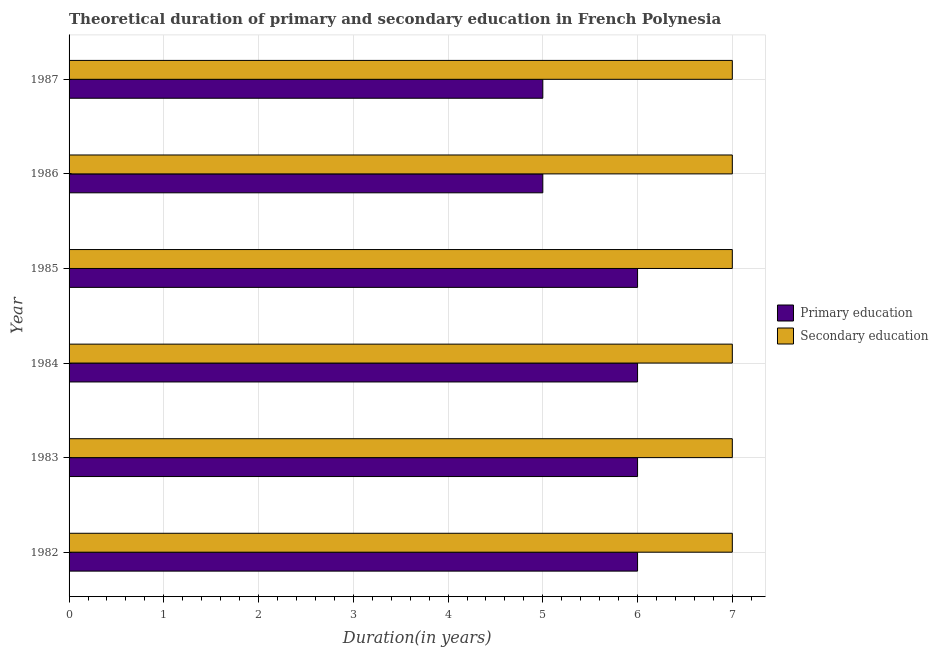How many different coloured bars are there?
Offer a terse response. 2. How many bars are there on the 3rd tick from the top?
Ensure brevity in your answer.  2. How many bars are there on the 1st tick from the bottom?
Your answer should be compact. 2. In how many cases, is the number of bars for a given year not equal to the number of legend labels?
Your answer should be very brief. 0. What is the duration of secondary education in 1986?
Provide a short and direct response. 7. Across all years, what is the maximum duration of secondary education?
Keep it short and to the point. 7. Across all years, what is the minimum duration of primary education?
Offer a terse response. 5. What is the total duration of secondary education in the graph?
Offer a terse response. 42. What is the difference between the duration of secondary education in 1983 and that in 1985?
Provide a short and direct response. 0. What is the difference between the duration of secondary education in 1984 and the duration of primary education in 1983?
Your answer should be compact. 1. What is the average duration of secondary education per year?
Keep it short and to the point. 7. In the year 1983, what is the difference between the duration of primary education and duration of secondary education?
Provide a succinct answer. -1. In how many years, is the duration of primary education greater than 3.4 years?
Ensure brevity in your answer.  6. What is the ratio of the duration of primary education in 1983 to that in 1986?
Ensure brevity in your answer.  1.2. What is the difference between the highest and the lowest duration of primary education?
Offer a terse response. 1. Is the sum of the duration of primary education in 1985 and 1987 greater than the maximum duration of secondary education across all years?
Your answer should be compact. Yes. What does the 2nd bar from the bottom in 1983 represents?
Give a very brief answer. Secondary education. What is the difference between two consecutive major ticks on the X-axis?
Give a very brief answer. 1. Are the values on the major ticks of X-axis written in scientific E-notation?
Provide a succinct answer. No. Does the graph contain any zero values?
Provide a succinct answer. No. Does the graph contain grids?
Keep it short and to the point. Yes. How are the legend labels stacked?
Give a very brief answer. Vertical. What is the title of the graph?
Provide a short and direct response. Theoretical duration of primary and secondary education in French Polynesia. What is the label or title of the X-axis?
Offer a terse response. Duration(in years). What is the label or title of the Y-axis?
Your response must be concise. Year. What is the Duration(in years) of Primary education in 1982?
Keep it short and to the point. 6. What is the Duration(in years) of Secondary education in 1983?
Provide a short and direct response. 7. What is the Duration(in years) in Primary education in 1985?
Ensure brevity in your answer.  6. What is the Duration(in years) of Primary education in 1987?
Keep it short and to the point. 5. What is the Duration(in years) of Secondary education in 1987?
Offer a very short reply. 7. Across all years, what is the minimum Duration(in years) in Primary education?
Provide a short and direct response. 5. What is the difference between the Duration(in years) in Secondary education in 1982 and that in 1983?
Offer a very short reply. 0. What is the difference between the Duration(in years) in Primary education in 1982 and that in 1984?
Your answer should be very brief. 0. What is the difference between the Duration(in years) of Secondary education in 1982 and that in 1985?
Offer a terse response. 0. What is the difference between the Duration(in years) in Primary education in 1982 and that in 1986?
Offer a terse response. 1. What is the difference between the Duration(in years) in Secondary education in 1982 and that in 1986?
Give a very brief answer. 0. What is the difference between the Duration(in years) of Primary education in 1982 and that in 1987?
Give a very brief answer. 1. What is the difference between the Duration(in years) of Secondary education in 1982 and that in 1987?
Your answer should be compact. 0. What is the difference between the Duration(in years) of Primary education in 1983 and that in 1984?
Your answer should be very brief. 0. What is the difference between the Duration(in years) in Secondary education in 1983 and that in 1984?
Provide a short and direct response. 0. What is the difference between the Duration(in years) in Primary education in 1983 and that in 1985?
Ensure brevity in your answer.  0. What is the difference between the Duration(in years) of Secondary education in 1983 and that in 1985?
Your answer should be very brief. 0. What is the difference between the Duration(in years) of Primary education in 1983 and that in 1986?
Keep it short and to the point. 1. What is the difference between the Duration(in years) in Secondary education in 1983 and that in 1986?
Provide a short and direct response. 0. What is the difference between the Duration(in years) in Secondary education in 1983 and that in 1987?
Offer a very short reply. 0. What is the difference between the Duration(in years) of Primary education in 1984 and that in 1986?
Offer a terse response. 1. What is the difference between the Duration(in years) in Secondary education in 1984 and that in 1987?
Your answer should be compact. 0. What is the difference between the Duration(in years) in Primary education in 1985 and that in 1986?
Your answer should be compact. 1. What is the difference between the Duration(in years) of Secondary education in 1985 and that in 1986?
Provide a succinct answer. 0. What is the difference between the Duration(in years) in Primary education in 1985 and that in 1987?
Keep it short and to the point. 1. What is the difference between the Duration(in years) in Secondary education in 1986 and that in 1987?
Your response must be concise. 0. What is the difference between the Duration(in years) of Primary education in 1982 and the Duration(in years) of Secondary education in 1983?
Ensure brevity in your answer.  -1. What is the difference between the Duration(in years) of Primary education in 1982 and the Duration(in years) of Secondary education in 1986?
Provide a succinct answer. -1. What is the difference between the Duration(in years) in Primary education in 1984 and the Duration(in years) in Secondary education in 1986?
Ensure brevity in your answer.  -1. What is the difference between the Duration(in years) in Primary education in 1985 and the Duration(in years) in Secondary education in 1986?
Your answer should be compact. -1. What is the difference between the Duration(in years) in Primary education in 1985 and the Duration(in years) in Secondary education in 1987?
Ensure brevity in your answer.  -1. What is the difference between the Duration(in years) in Primary education in 1986 and the Duration(in years) in Secondary education in 1987?
Make the answer very short. -2. What is the average Duration(in years) of Primary education per year?
Provide a short and direct response. 5.67. In the year 1982, what is the difference between the Duration(in years) in Primary education and Duration(in years) in Secondary education?
Offer a terse response. -1. In the year 1983, what is the difference between the Duration(in years) in Primary education and Duration(in years) in Secondary education?
Keep it short and to the point. -1. In the year 1985, what is the difference between the Duration(in years) in Primary education and Duration(in years) in Secondary education?
Your answer should be compact. -1. In the year 1986, what is the difference between the Duration(in years) of Primary education and Duration(in years) of Secondary education?
Provide a short and direct response. -2. What is the ratio of the Duration(in years) in Secondary education in 1982 to that in 1983?
Your answer should be very brief. 1. What is the ratio of the Duration(in years) of Primary education in 1982 to that in 1984?
Your response must be concise. 1. What is the ratio of the Duration(in years) in Primary education in 1982 to that in 1987?
Your answer should be compact. 1.2. What is the ratio of the Duration(in years) of Secondary education in 1983 to that in 1985?
Provide a short and direct response. 1. What is the ratio of the Duration(in years) in Primary education in 1983 to that in 1986?
Offer a terse response. 1.2. What is the ratio of the Duration(in years) in Secondary education in 1983 to that in 1986?
Offer a very short reply. 1. What is the ratio of the Duration(in years) in Secondary education in 1983 to that in 1987?
Provide a short and direct response. 1. What is the ratio of the Duration(in years) in Primary education in 1984 to that in 1985?
Offer a very short reply. 1. What is the ratio of the Duration(in years) of Secondary education in 1984 to that in 1985?
Ensure brevity in your answer.  1. What is the ratio of the Duration(in years) of Primary education in 1984 to that in 1987?
Provide a succinct answer. 1.2. What is the ratio of the Duration(in years) in Secondary education in 1984 to that in 1987?
Offer a very short reply. 1. What is the ratio of the Duration(in years) in Primary education in 1985 to that in 1986?
Make the answer very short. 1.2. What is the ratio of the Duration(in years) of Secondary education in 1985 to that in 1986?
Your answer should be compact. 1. What is the ratio of the Duration(in years) in Secondary education in 1985 to that in 1987?
Your answer should be very brief. 1. What is the ratio of the Duration(in years) in Primary education in 1986 to that in 1987?
Your answer should be compact. 1. What is the ratio of the Duration(in years) in Secondary education in 1986 to that in 1987?
Your answer should be compact. 1. What is the difference between the highest and the second highest Duration(in years) in Secondary education?
Your answer should be very brief. 0. What is the difference between the highest and the lowest Duration(in years) in Primary education?
Provide a short and direct response. 1. 